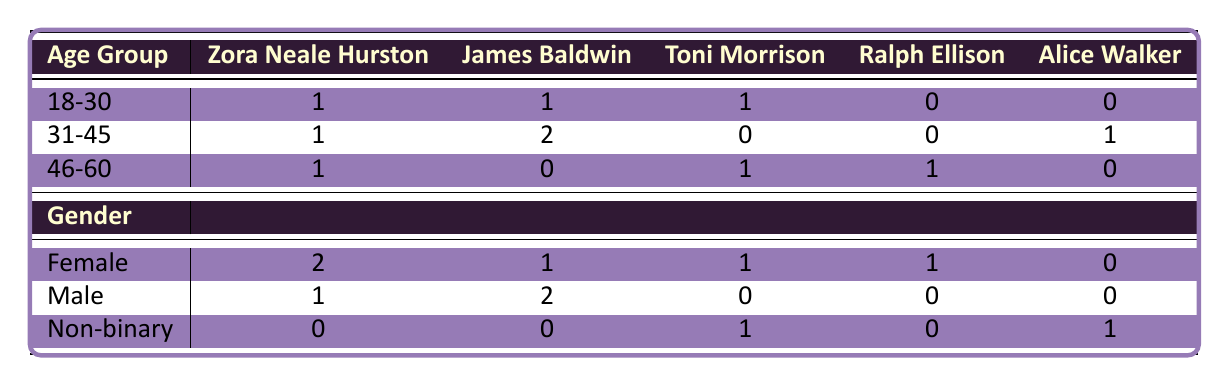What is the number of book club members who prefer Zora Neale Hurston? By looking at the column for Zora Neale Hurston in the table, we can count the number of occurrences across different age groups and genders. There are three instances: one in the age group of 18-30, one in 31-45, and one in 46-60.
Answer: 3 Which preferred author has the most female members? In the Female row, we check the counts across all preferred authors. Zora Neale Hurston has the highest count with two members, compared to others (James Baldwin and Toni Morrison with one each).
Answer: Zora Neale Hurston Is there a gender associated with preferring Alice Walker? We look at the Non-binary row for Alice Walker, which shows one member. Since no other gender is associated with Alice Walker, the answer is true that a gender is associated.
Answer: Yes How many male members prefer James Baldwin compared to Toni Morrison? The Male row indicates that two members prefer James Baldwin and zero members prefer Toni Morrison. Therefore, the difference is 2 - 0 = 2.
Answer: 2 For the age group 31-45, which author is preferred the least? In the 31-45 age group, we observe the counts: Zora Neale Hurston (1), James Baldwin (2), Toni Morrison (0), Ralph Ellison (0), and Alice Walker (1). The least preferred authors, with a count of zero, are Toni Morrison and Ralph Ellison.
Answer: Toni Morrison and Ralph Ellison How many total members are in the book club? To find the total members, we can simply count each member listed in the data. There are ten members in total.
Answer: 10 Do any non-binary members prefer James Baldwin? We check the Non-binary row, which shows zero members preferring James Baldwin. Therefore, the statement is false.
Answer: No What is the total number of preferred authors listed for the age group 46-60? In the 46-60 group, we count the occurrences for each preferred author: Zora Neale Hurston (1), James Baldwin (0), Toni Morrison (1), Ralph Ellison (1), and Alice Walker (0). Thus, the total is 1 + 0 + 1 + 1 + 0 = 3.
Answer: 3 